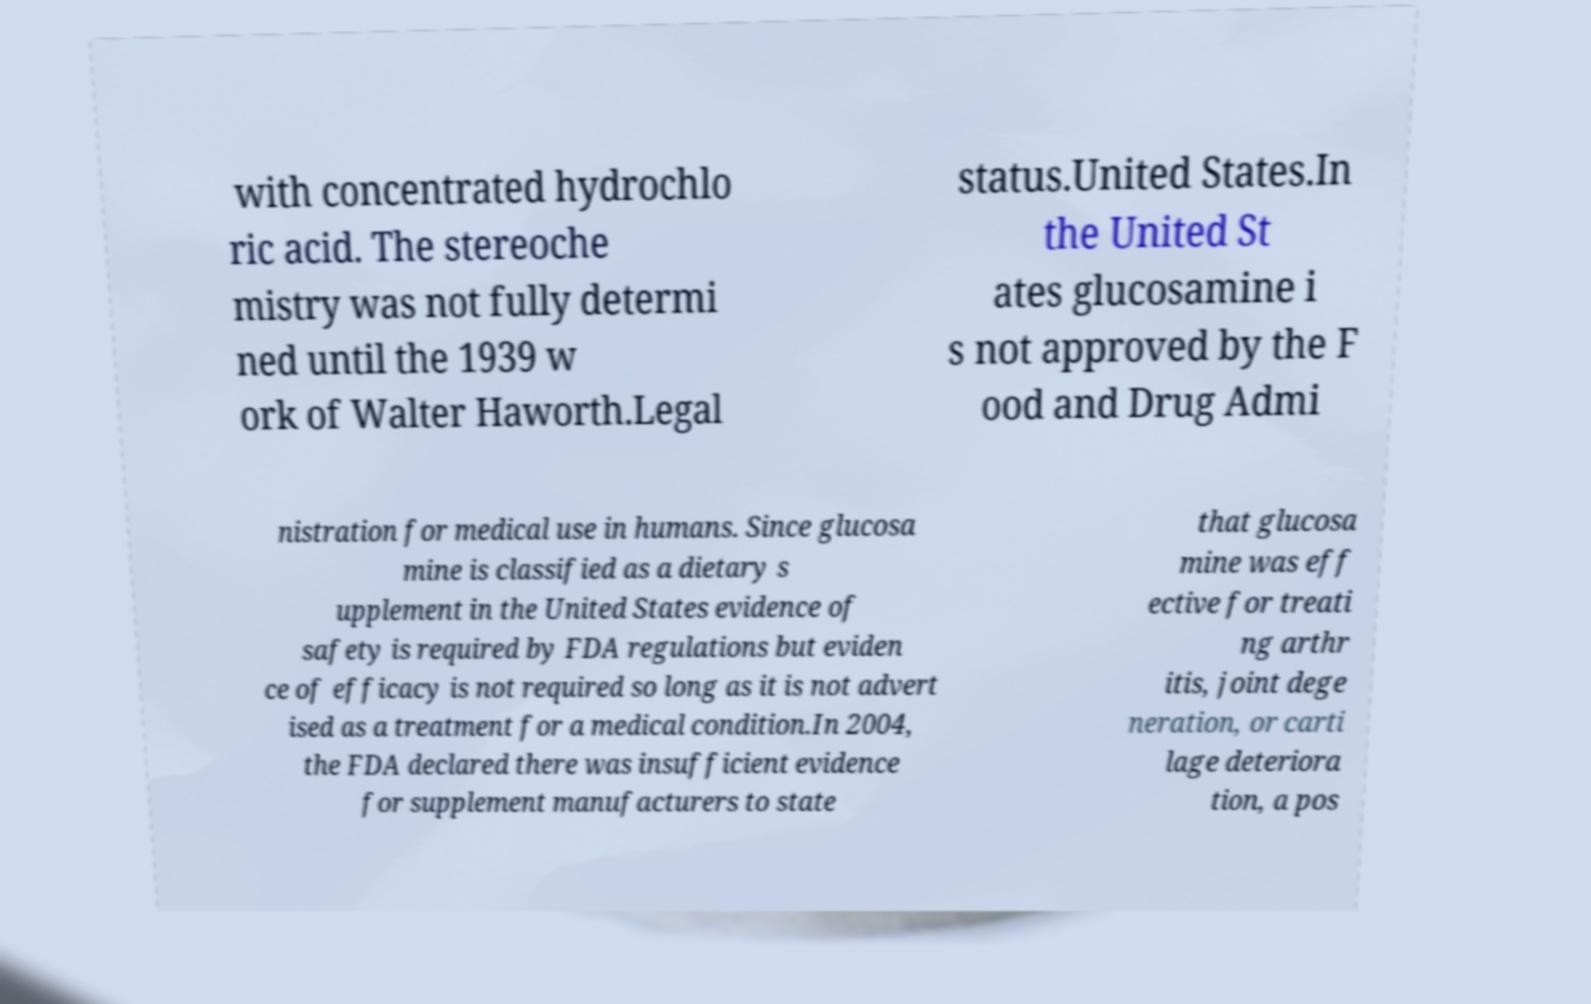I need the written content from this picture converted into text. Can you do that? with concentrated hydrochlo ric acid. The stereoche mistry was not fully determi ned until the 1939 w ork of Walter Haworth.Legal status.United States.In the United St ates glucosamine i s not approved by the F ood and Drug Admi nistration for medical use in humans. Since glucosa mine is classified as a dietary s upplement in the United States evidence of safety is required by FDA regulations but eviden ce of efficacy is not required so long as it is not advert ised as a treatment for a medical condition.In 2004, the FDA declared there was insufficient evidence for supplement manufacturers to state that glucosa mine was eff ective for treati ng arthr itis, joint dege neration, or carti lage deteriora tion, a pos 